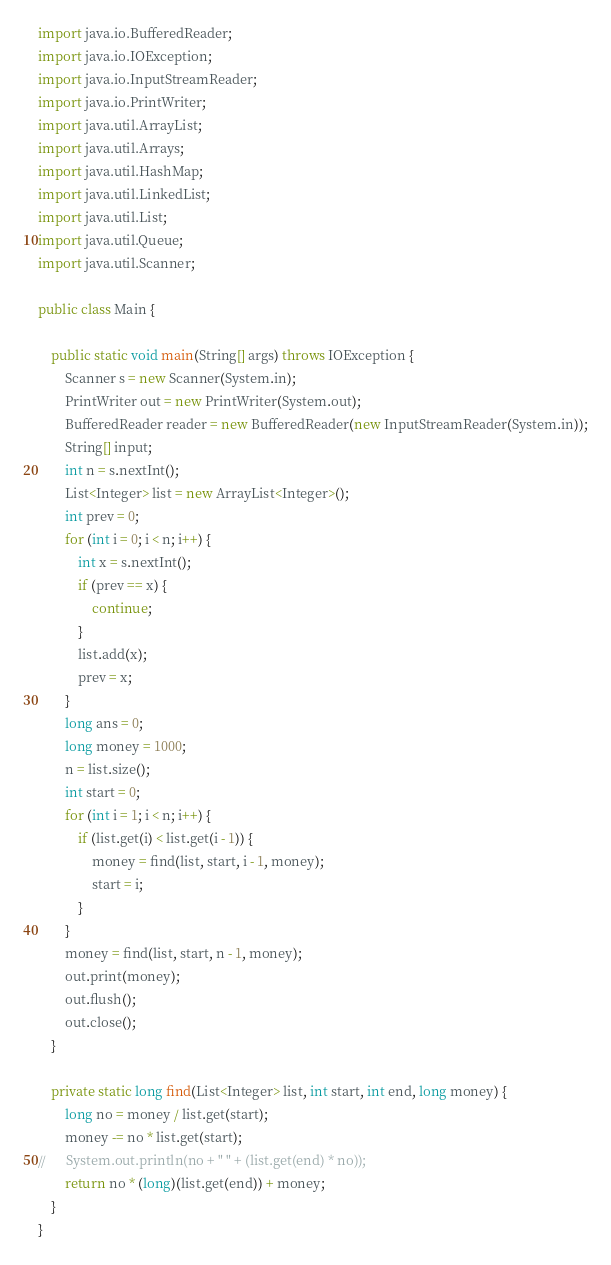Convert code to text. <code><loc_0><loc_0><loc_500><loc_500><_Java_>import java.io.BufferedReader;
import java.io.IOException;
import java.io.InputStreamReader;
import java.io.PrintWriter;
import java.util.ArrayList;
import java.util.Arrays;
import java.util.HashMap;
import java.util.LinkedList;
import java.util.List;
import java.util.Queue;
import java.util.Scanner;

public class Main {
	
    public static void main(String[] args) throws IOException {
    	Scanner s = new Scanner(System.in);
		PrintWriter out = new PrintWriter(System.out);
		BufferedReader reader = new BufferedReader(new InputStreamReader(System.in));
		String[] input;
		int n = s.nextInt();
		List<Integer> list = new ArrayList<Integer>();
		int prev = 0;
		for (int i = 0; i < n; i++) {
			int x = s.nextInt();
			if (prev == x) {
				continue;
			}
			list.add(x);
			prev = x;
		}
		long ans = 0;
		long money = 1000;
		n = list.size();
		int start = 0;
		for (int i = 1; i < n; i++) {
			if (list.get(i) < list.get(i - 1)) {
				money = find(list, start, i - 1, money);
				start = i;
			}
		}
		money = find(list, start, n - 1, money);
		out.print(money);
		out.flush();
		out.close();
    }

	private static long find(List<Integer> list, int start, int end, long money) {
		long no = money / list.get(start);
		money -= no * list.get(start);
//		System.out.println(no + " " + (list.get(end) * no));
		return no * (long)(list.get(end)) + money;
	}
}
</code> 